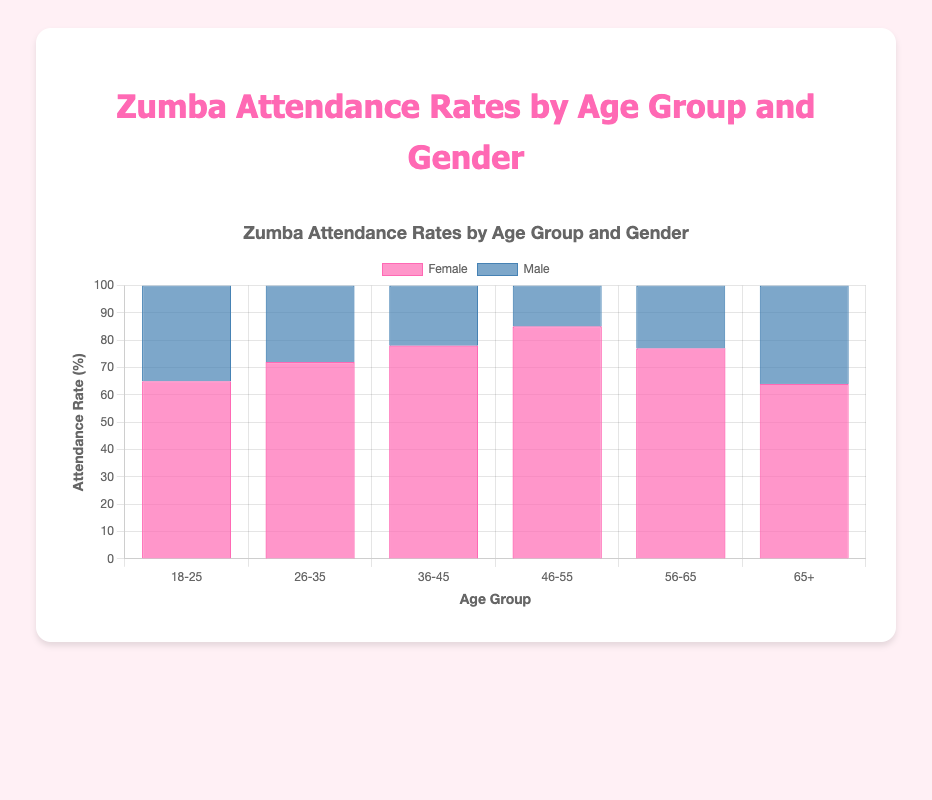What is the attendance rate for males aged 26-35? Locate the bar corresponding to males in the 26-35 age group and read the value on that bar. The attendance rate is 28%.
Answer: 28% Which age group has the highest attendance rate for females? Compare the heights of all the bars representing female attendance rates across different age groups. The age group 46-55 has the highest bar at 85%.
Answer: 46-55 How much higher is the attendance rate for females aged 36-45 compared to males in the same age group? Find the bars for both females and males in the 36-45 age group. The female attendance rate is 78%, and the male attendance rate is 22%. The difference is 78% - 22% = 56%.
Answer: 56% In which age group is the difference in attendance rate between females and males the smallest? Calculate the difference in attendance rates for each age group. Find the minimum difference:
18-25: 65% - 35% = 30%
26-35: 72% - 28% = 44%
36-45: 78% - 22% = 56%
46-55: 85% - 15% = 70%
56-65: 77% - 23% = 54%
65+: 64% - 36% = 28%. The smallest difference is in the 65+ age group.
Answer: 65+ What is the average attendance rate for females across all age groups? Sum the attendance rates for females in all age groups and divide by the number of age groups: (65% + 72% + 78% + 85% + 77% + 64%) / 6 = 441% / 6 = 73.5%.
Answer: 73.5% What is the combined attendance rate for both genders in the 56-65 age group? Sum the attendance rates for both males and females in the 56-65 age group: 77% (female) + 23% (male) = 100%.
Answer: 100% Compare the attendance rates of males aged 18-25 and 36-45. Which is higher? Look at the attendance rates of males in the 18-25 age group and the 36-45 age group. The attendance rates are 35% (18-25) and 22% (36-45). The 18-25 age group has a higher attendance rate.
Answer: 18-25 Is there a visual pattern in attendance rates that signifies an age group preference among males or females? Observing the trend in the heights of the bars, it is clear that females generally have higher attendance rates across all age groups compared to males. Both males and females seem to have relatively high attendance during the 18-25 and 46-55 age groups.
Answer: Females have higher attendance rates across age groups Which gender has the most consistent attendance rates across different age groups? Compare the consistency of attendance rate bars for both genders. Female attendance rates range from 64% to 85%, while male rates range from 15% to 36%. Females have a narrower range, implying more consistency.
Answer: Females 